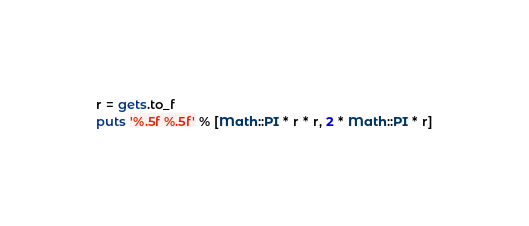Convert code to text. <code><loc_0><loc_0><loc_500><loc_500><_Ruby_>r = gets.to_f
puts '%.5f %.5f' % [Math::PI * r * r, 2 * Math::PI * r]</code> 